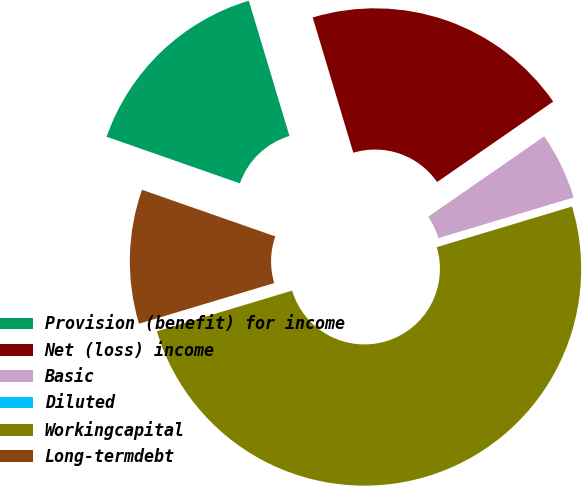<chart> <loc_0><loc_0><loc_500><loc_500><pie_chart><fcel>Provision (benefit) for income<fcel>Net (loss) income<fcel>Basic<fcel>Diluted<fcel>Workingcapital<fcel>Long-termdebt<nl><fcel>15.0%<fcel>20.0%<fcel>5.0%<fcel>0.0%<fcel>50.0%<fcel>10.0%<nl></chart> 